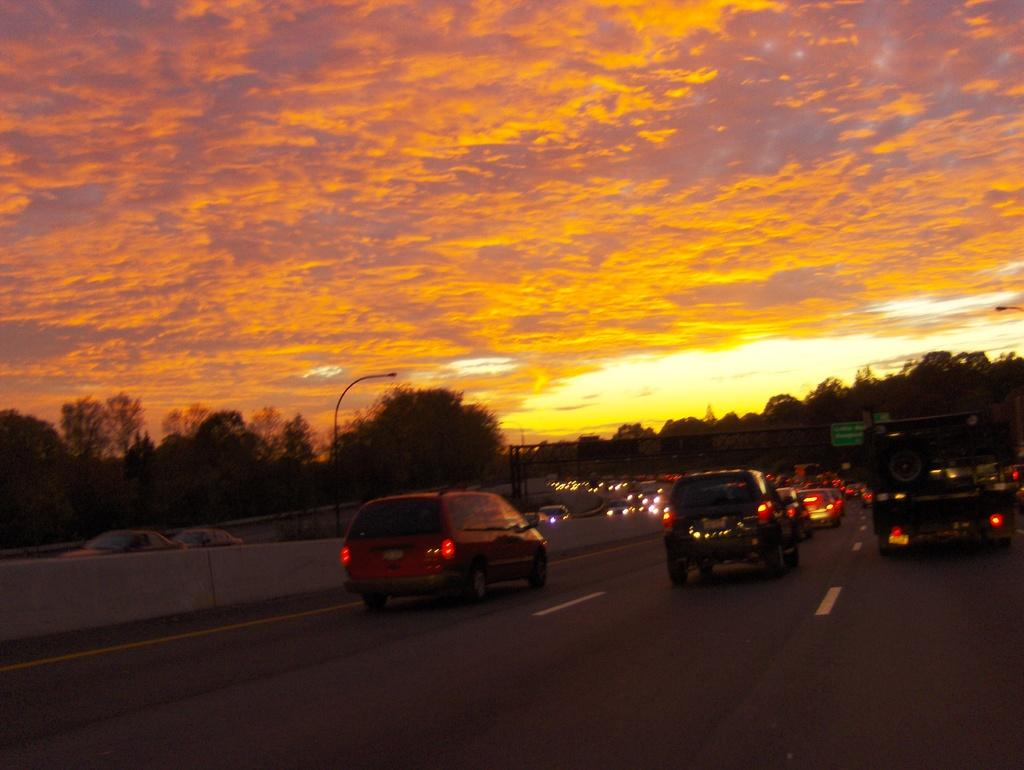What is happening on the road in the image? There are cars moving on the road in the image. What can be seen in the background of the image? There are trees in the background of the image. What structures are present in the image? There are poles in the image. What is the weather like in the image? The sky is cloudy in the image. What type of holiday is being celebrated by the laborers in the image? There are no laborers or holiday celebrations present in the image. What route are the cars taking in the image? The image does not show the specific route the cars are taking; it only shows them moving on the road. 